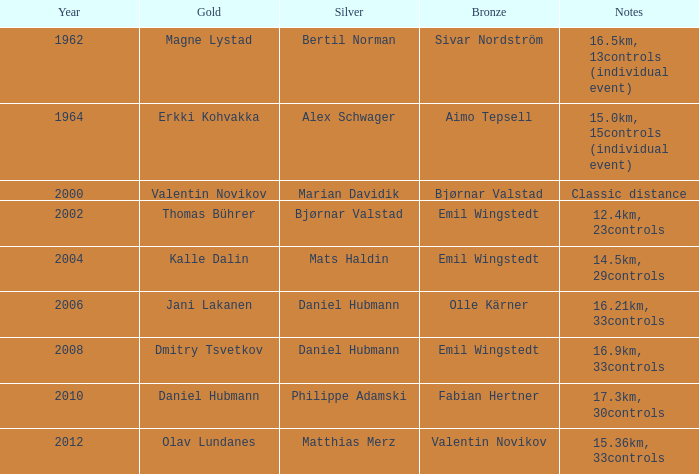WHAT IS THE YEAR WITH A BRONZE OF AIMO TEPSELL? 1964.0. 